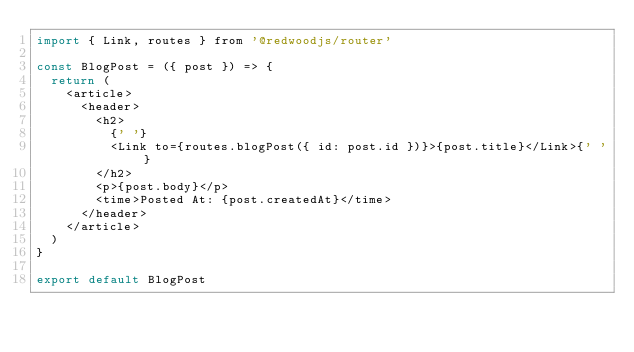Convert code to text. <code><loc_0><loc_0><loc_500><loc_500><_JavaScript_>import { Link, routes } from '@redwoodjs/router'

const BlogPost = ({ post }) => {
  return (
    <article>
      <header>
        <h2>
          {' '}
          <Link to={routes.blogPost({ id: post.id })}>{post.title}</Link>{' '}
        </h2>
        <p>{post.body}</p>
        <time>Posted At: {post.createdAt}</time>
      </header>
    </article>
  )
}

export default BlogPost
</code> 